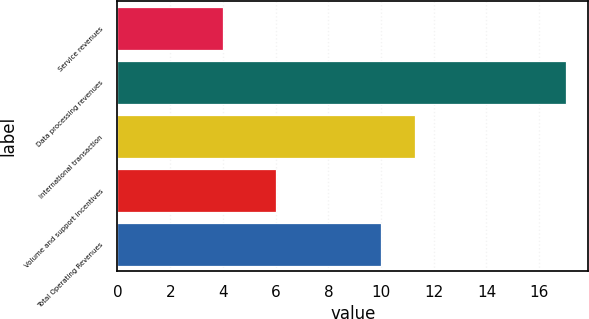Convert chart. <chart><loc_0><loc_0><loc_500><loc_500><bar_chart><fcel>Service revenues<fcel>Data processing revenues<fcel>International transaction<fcel>Volume and support incentives<fcel>Total Operating Revenues<nl><fcel>4<fcel>17<fcel>11.3<fcel>6<fcel>10<nl></chart> 